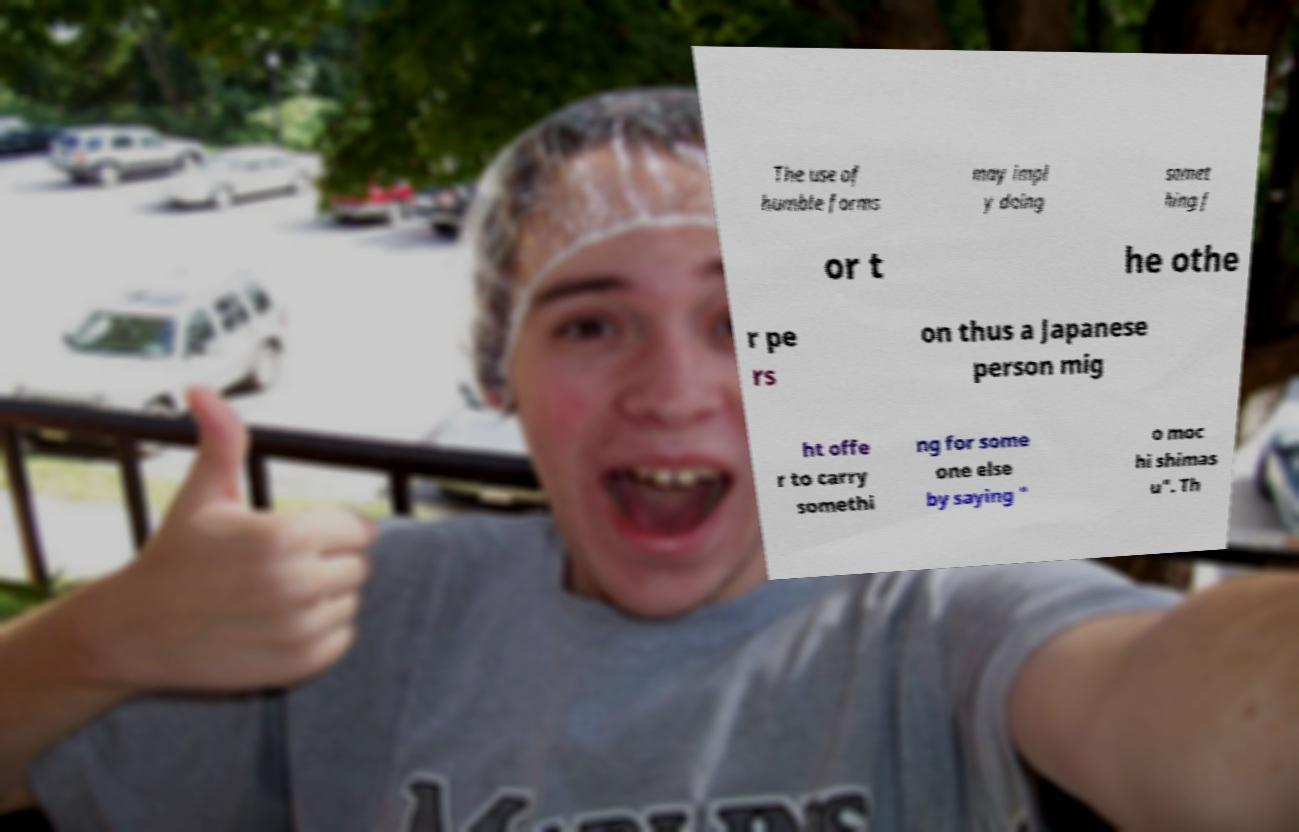Please identify and transcribe the text found in this image. The use of humble forms may impl y doing somet hing f or t he othe r pe rs on thus a Japanese person mig ht offe r to carry somethi ng for some one else by saying " o moc hi shimas u". Th 